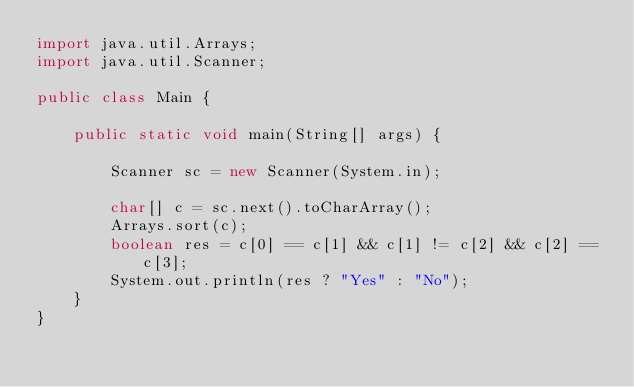<code> <loc_0><loc_0><loc_500><loc_500><_Java_>import java.util.Arrays;
import java.util.Scanner;

public class Main {

    public static void main(String[] args) {

        Scanner sc = new Scanner(System.in);

        char[] c = sc.next().toCharArray();
        Arrays.sort(c);
        boolean res = c[0] == c[1] && c[1] != c[2] && c[2] == c[3];
        System.out.println(res ? "Yes" : "No");
    }
}
</code> 